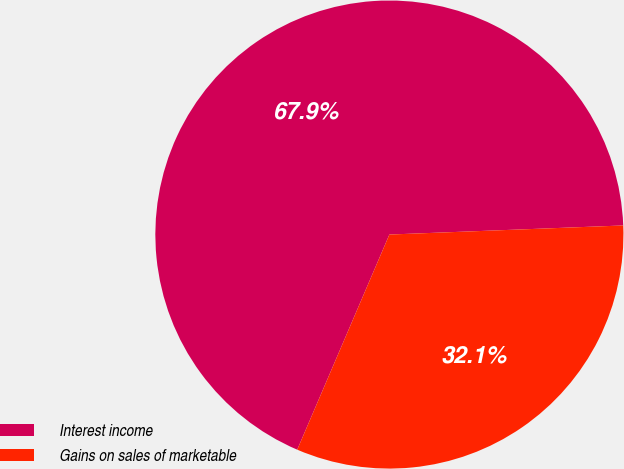Convert chart to OTSL. <chart><loc_0><loc_0><loc_500><loc_500><pie_chart><fcel>Interest income<fcel>Gains on sales of marketable<nl><fcel>67.94%<fcel>32.06%<nl></chart> 